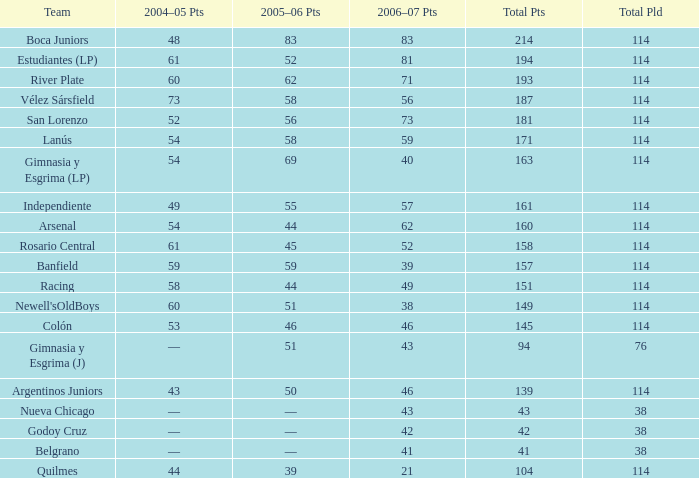Parse the full table. {'header': ['Team', '2004–05 Pts', '2005–06 Pts', '2006–07 Pts', 'Total Pts', 'Total Pld'], 'rows': [['Boca Juniors', '48', '83', '83', '214', '114'], ['Estudiantes (LP)', '61', '52', '81', '194', '114'], ['River Plate', '60', '62', '71', '193', '114'], ['Vélez Sársfield', '73', '58', '56', '187', '114'], ['San Lorenzo', '52', '56', '73', '181', '114'], ['Lanús', '54', '58', '59', '171', '114'], ['Gimnasia y Esgrima (LP)', '54', '69', '40', '163', '114'], ['Independiente', '49', '55', '57', '161', '114'], ['Arsenal', '54', '44', '62', '160', '114'], ['Rosario Central', '61', '45', '52', '158', '114'], ['Banfield', '59', '59', '39', '157', '114'], ['Racing', '58', '44', '49', '151', '114'], ["Newell'sOldBoys", '60', '51', '38', '149', '114'], ['Colón', '53', '46', '46', '145', '114'], ['Gimnasia y Esgrima (J)', '—', '51', '43', '94', '76'], ['Argentinos Juniors', '43', '50', '46', '139', '114'], ['Nueva Chicago', '—', '—', '43', '43', '38'], ['Godoy Cruz', '—', '—', '42', '42', '38'], ['Belgrano', '—', '—', '41', '41', '38'], ['Quilmes', '44', '39', '21', '104', '114']]} What is the aggregate number of points for a total pld less than 38? 0.0. 